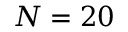Convert formula to latex. <formula><loc_0><loc_0><loc_500><loc_500>N = 2 0</formula> 